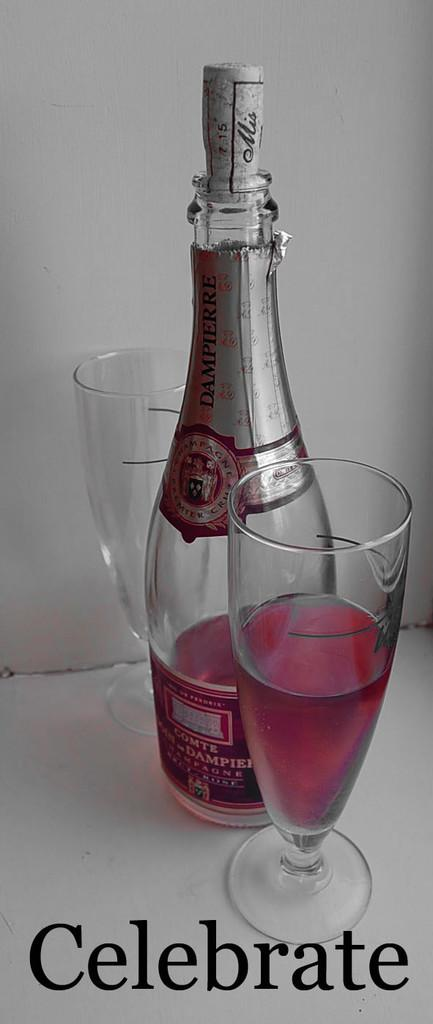<image>
Share a concise interpretation of the image provided. Two glasses are on either side of a bottle of sparkling wine, and the word "celebrate" is written underneath. 